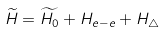<formula> <loc_0><loc_0><loc_500><loc_500>\widetilde { H } = \widetilde { H _ { 0 } } + H _ { e - e } + H _ { \triangle }</formula> 